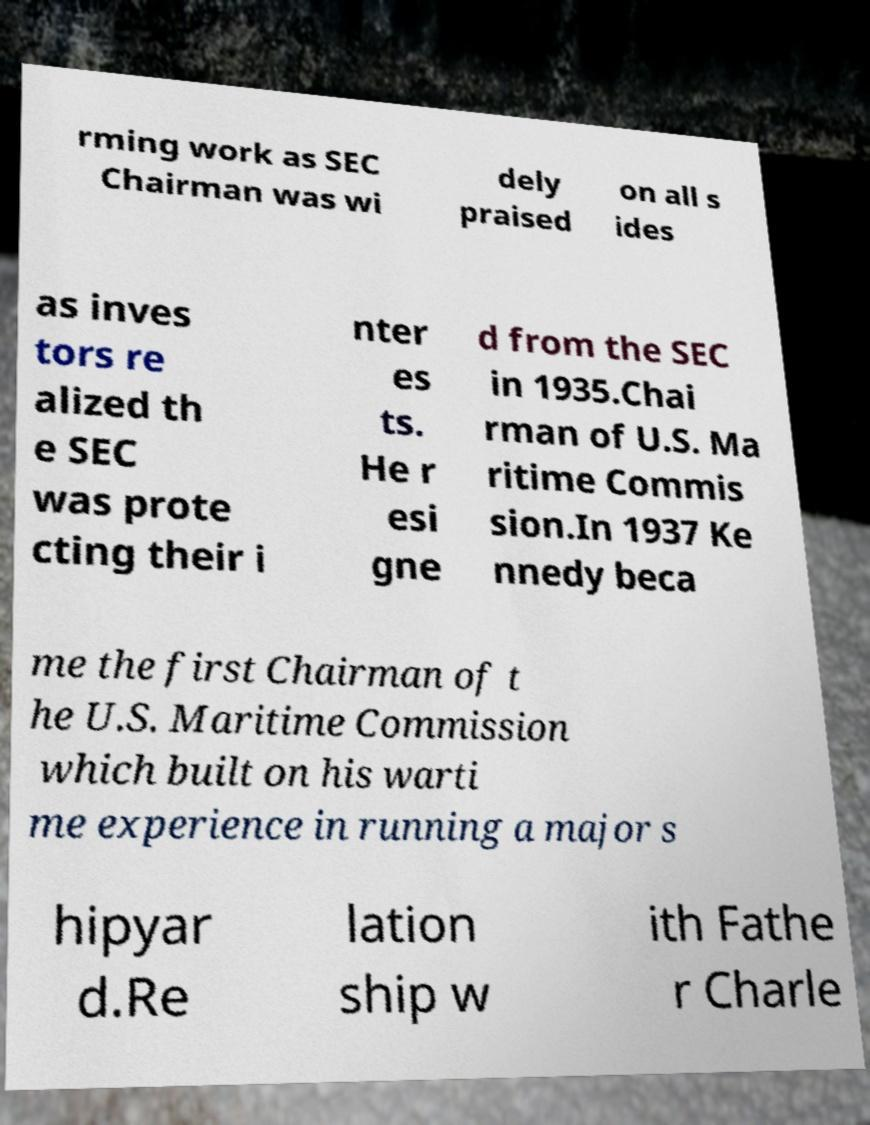Can you read and provide the text displayed in the image?This photo seems to have some interesting text. Can you extract and type it out for me? rming work as SEC Chairman was wi dely praised on all s ides as inves tors re alized th e SEC was prote cting their i nter es ts. He r esi gne d from the SEC in 1935.Chai rman of U.S. Ma ritime Commis sion.In 1937 Ke nnedy beca me the first Chairman of t he U.S. Maritime Commission which built on his warti me experience in running a major s hipyar d.Re lation ship w ith Fathe r Charle 